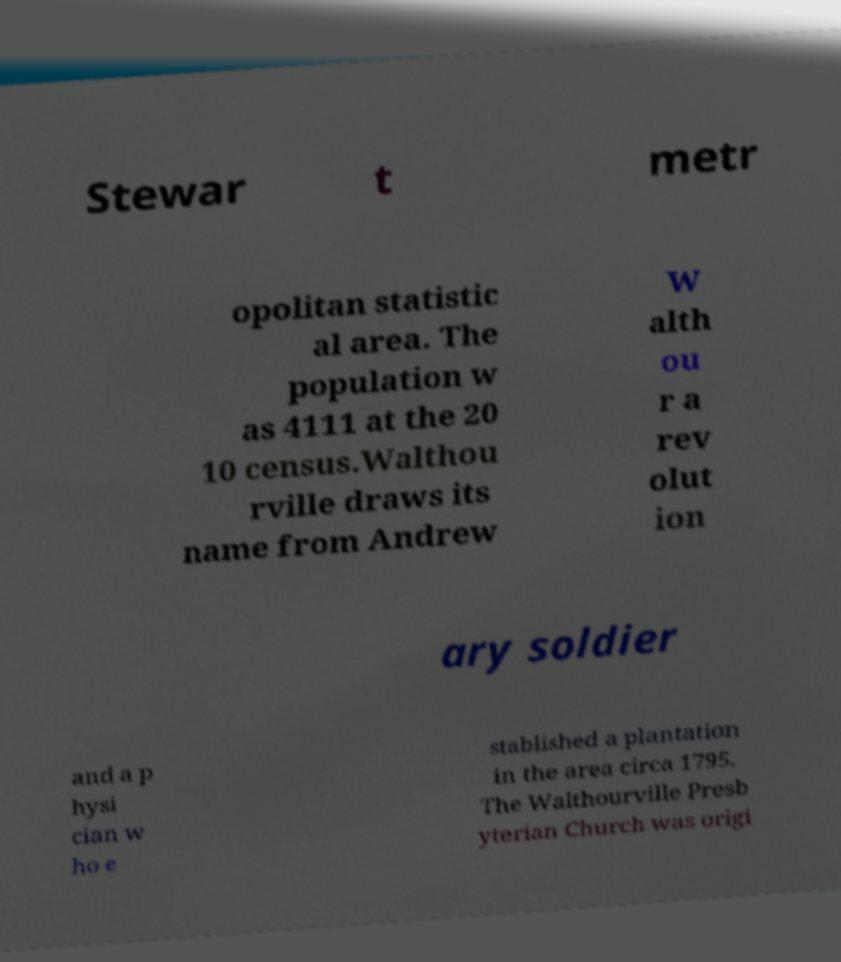I need the written content from this picture converted into text. Can you do that? Stewar t metr opolitan statistic al area. The population w as 4111 at the 20 10 census.Walthou rville draws its name from Andrew W alth ou r a rev olut ion ary soldier and a p hysi cian w ho e stablished a plantation in the area circa 1795. The Walthourville Presb yterian Church was origi 